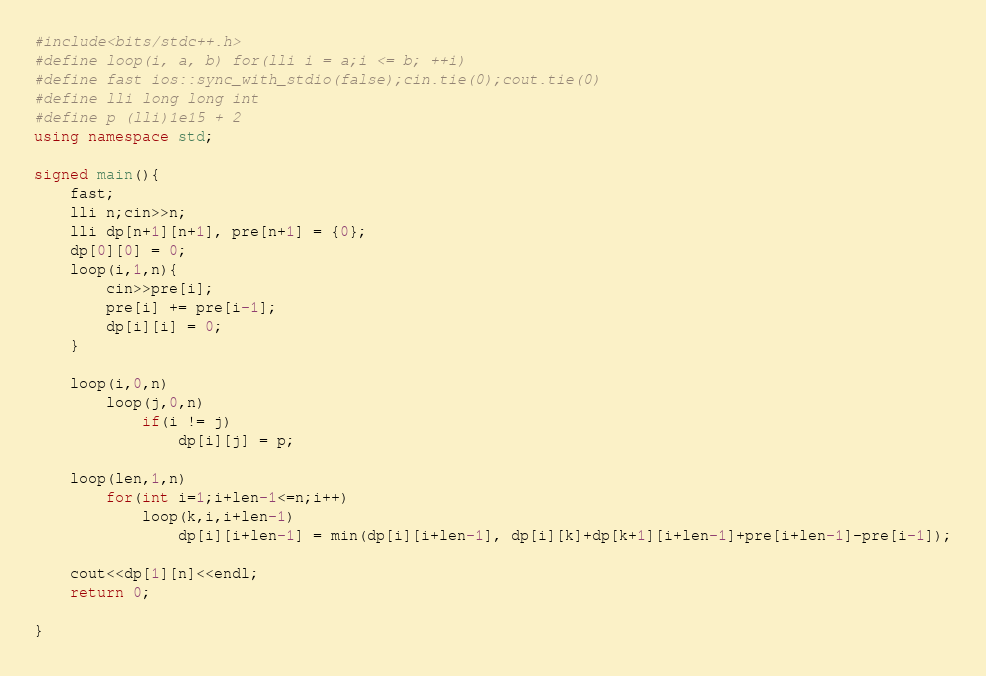Convert code to text. <code><loc_0><loc_0><loc_500><loc_500><_C++_>#include<bits/stdc++.h>
#define loop(i, a, b) for(lli i = a;i <= b; ++i)
#define fast ios::sync_with_stdio(false);cin.tie(0);cout.tie(0)
#define lli long long int 
#define p (lli)1e15 + 2
using namespace std;
 
signed main(){
    fast;
    lli n;cin>>n;
    lli dp[n+1][n+1], pre[n+1] = {0};
    dp[0][0] = 0;
    loop(i,1,n){
        cin>>pre[i];
        pre[i] += pre[i-1];
        dp[i][i] = 0;
    }

    loop(i,0,n)
        loop(j,0,n)
            if(i != j)
                dp[i][j] = p;

    loop(len,1,n)
        for(int i=1;i+len-1<=n;i++)
            loop(k,i,i+len-1)
                dp[i][i+len-1] = min(dp[i][i+len-1], dp[i][k]+dp[k+1][i+len-1]+pre[i+len-1]-pre[i-1]);

    cout<<dp[1][n]<<endl;
    return 0;
        
}</code> 